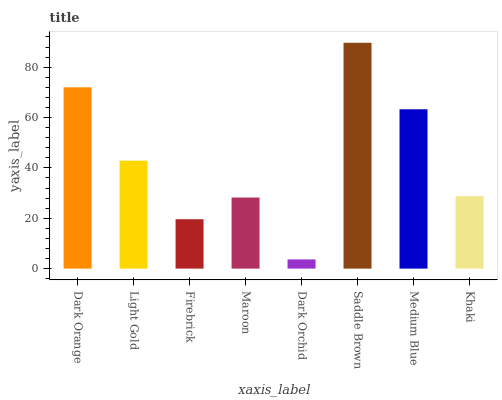Is Dark Orchid the minimum?
Answer yes or no. Yes. Is Saddle Brown the maximum?
Answer yes or no. Yes. Is Light Gold the minimum?
Answer yes or no. No. Is Light Gold the maximum?
Answer yes or no. No. Is Dark Orange greater than Light Gold?
Answer yes or no. Yes. Is Light Gold less than Dark Orange?
Answer yes or no. Yes. Is Light Gold greater than Dark Orange?
Answer yes or no. No. Is Dark Orange less than Light Gold?
Answer yes or no. No. Is Light Gold the high median?
Answer yes or no. Yes. Is Khaki the low median?
Answer yes or no. Yes. Is Dark Orchid the high median?
Answer yes or no. No. Is Maroon the low median?
Answer yes or no. No. 